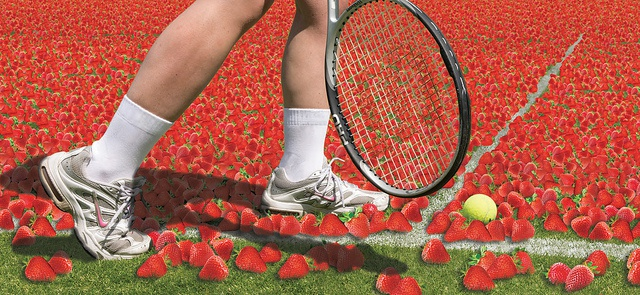Describe the objects in this image and their specific colors. I can see people in tan, lightgray, gray, and darkgray tones, tennis racket in tan, red, salmon, gray, and black tones, and sports ball in tan, khaki, and olive tones in this image. 